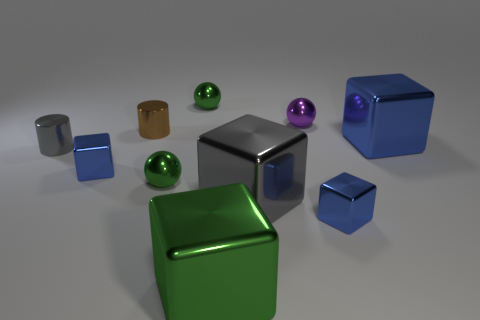Is there a green shiny cube of the same size as the purple sphere?
Offer a very short reply. No. The brown thing that is left of the blue block behind the tiny gray cylinder is made of what material?
Offer a terse response. Metal. The tiny gray object that is the same material as the purple thing is what shape?
Your response must be concise. Cylinder. What is the size of the ball on the right side of the big gray metallic cube?
Keep it short and to the point. Small. Are there an equal number of big gray things that are in front of the big blue thing and tiny blue cubes on the right side of the big green block?
Make the answer very short. Yes. There is a metal object that is in front of the tiny cube to the right of the tiny shiny block that is left of the purple metal thing; what is its color?
Ensure brevity in your answer.  Green. What number of tiny objects are both right of the brown shiny thing and on the left side of the large gray shiny object?
Offer a very short reply. 2. Do the cylinder that is in front of the brown metallic thing and the block to the left of the brown shiny cylinder have the same color?
Give a very brief answer. No. Is there any other thing that is made of the same material as the small gray cylinder?
Give a very brief answer. Yes. What size is the gray metal object that is the same shape as the big green shiny object?
Provide a succinct answer. Large. 